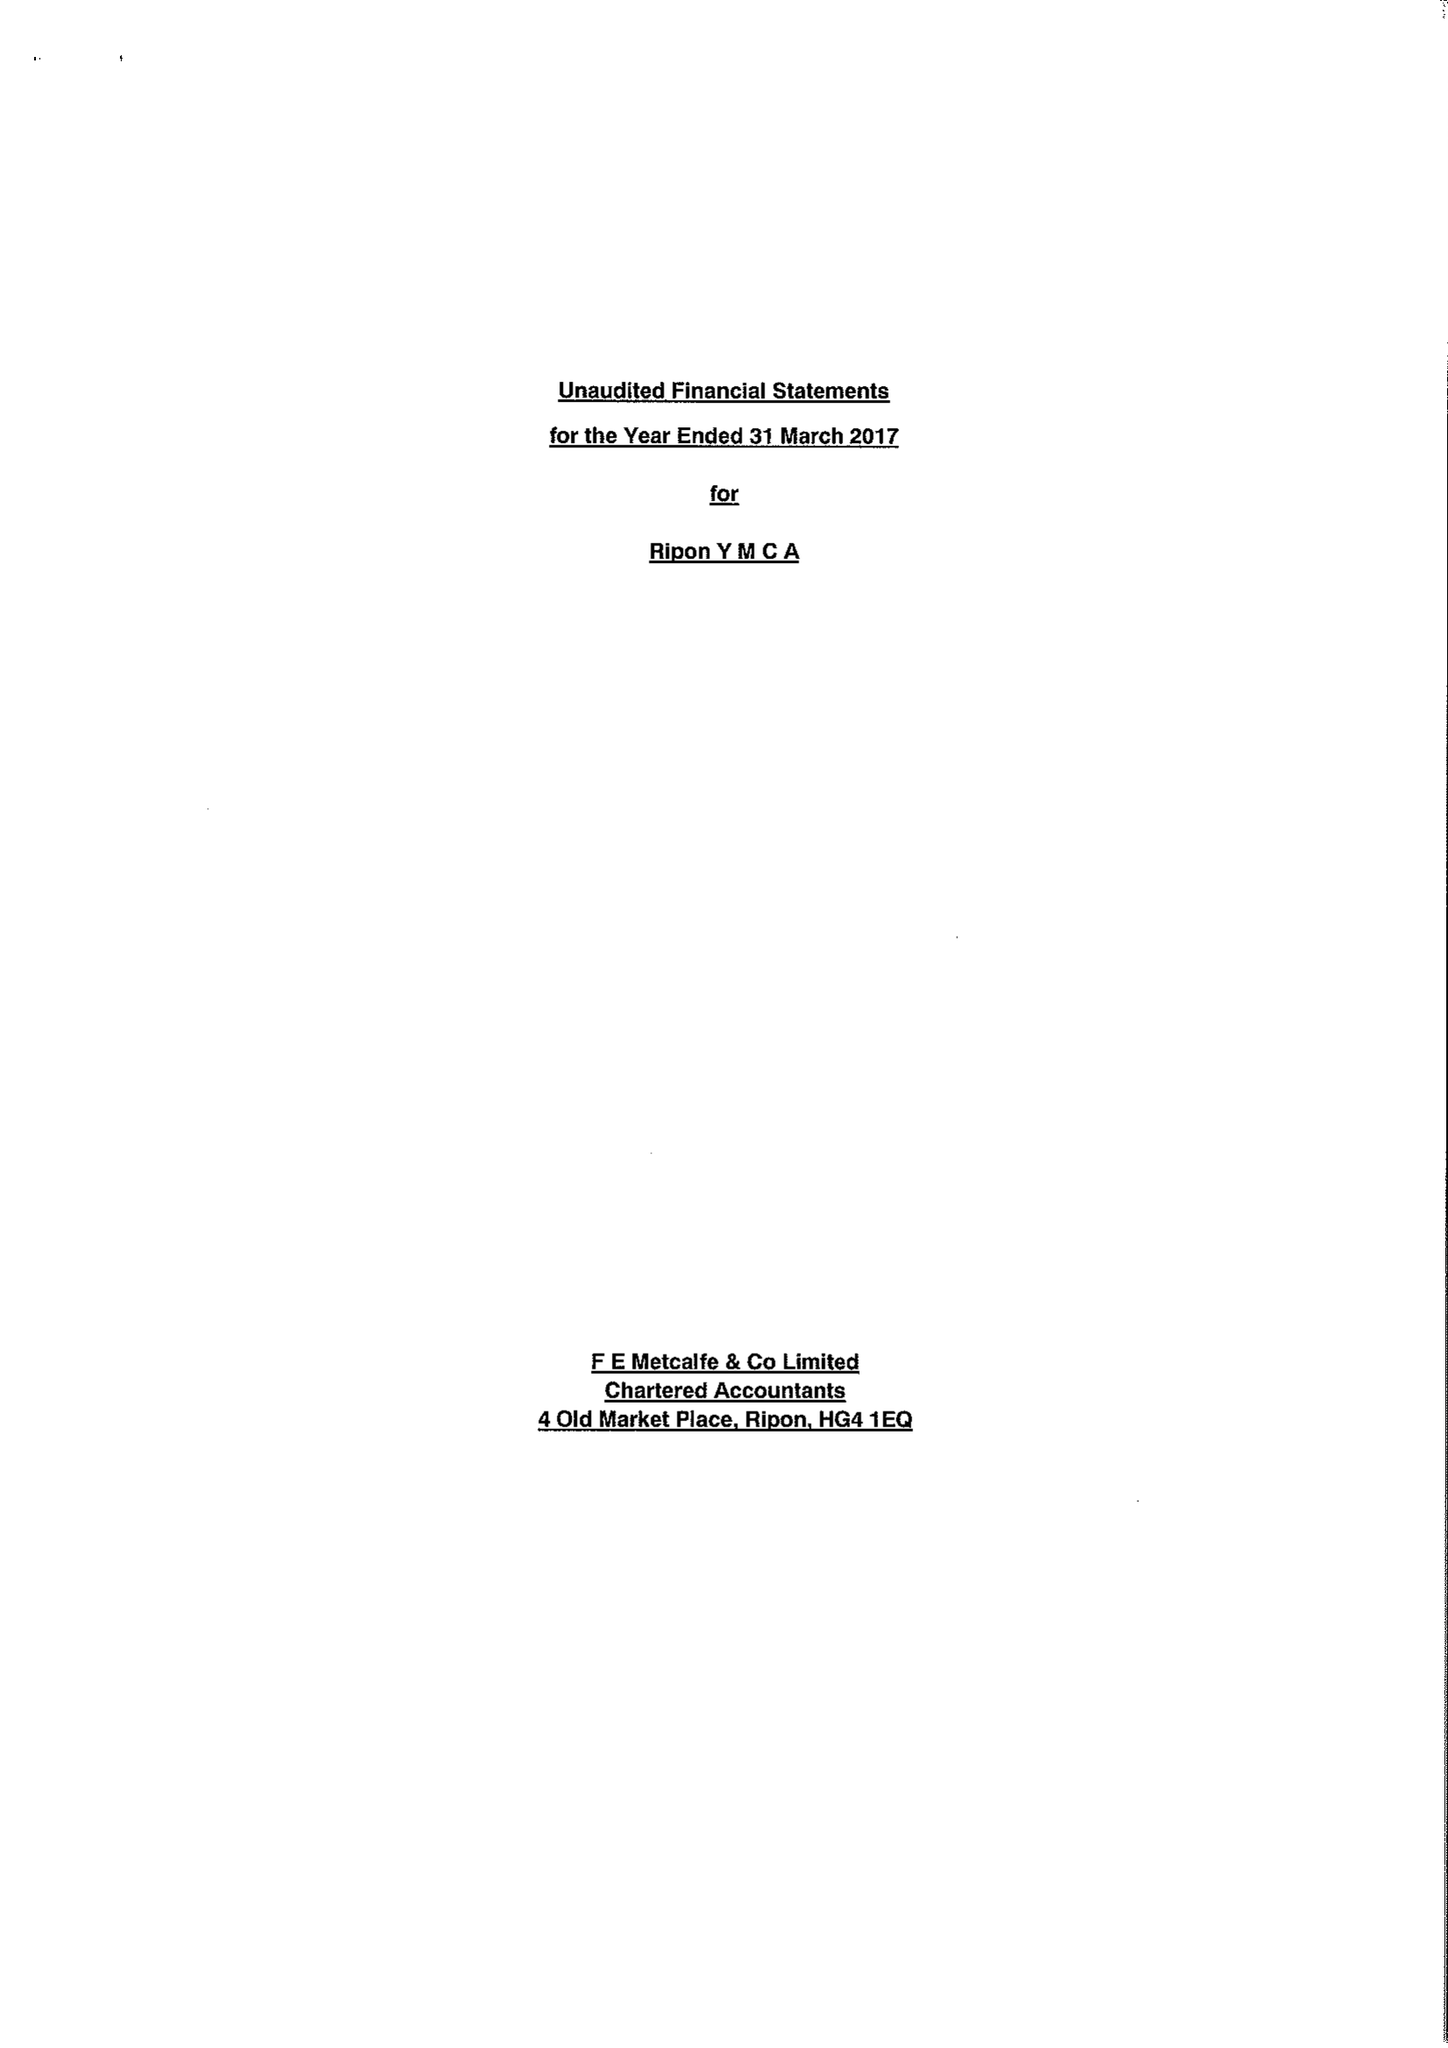What is the value for the address__street_line?
Answer the question using a single word or phrase. 4-5 WATER SKELLGATE 